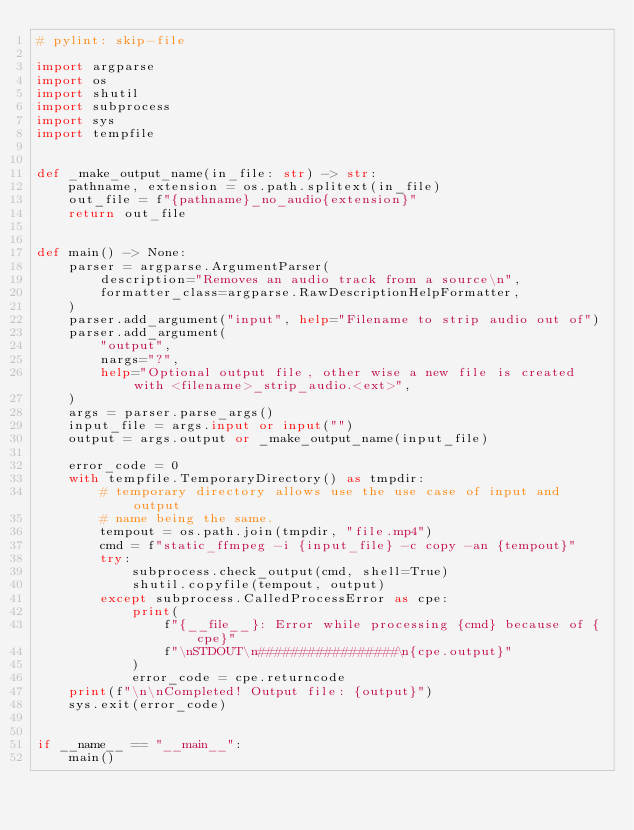<code> <loc_0><loc_0><loc_500><loc_500><_Python_># pylint: skip-file

import argparse
import os
import shutil
import subprocess
import sys
import tempfile


def _make_output_name(in_file: str) -> str:
    pathname, extension = os.path.splitext(in_file)
    out_file = f"{pathname}_no_audio{extension}"
    return out_file


def main() -> None:
    parser = argparse.ArgumentParser(
        description="Removes an audio track from a source\n",
        formatter_class=argparse.RawDescriptionHelpFormatter,
    )
    parser.add_argument("input", help="Filename to strip audio out of")
    parser.add_argument(
        "output",
        nargs="?",
        help="Optional output file, other wise a new file is created with <filename>_strip_audio.<ext>",
    )
    args = parser.parse_args()
    input_file = args.input or input("")
    output = args.output or _make_output_name(input_file)

    error_code = 0
    with tempfile.TemporaryDirectory() as tmpdir:
        # temporary directory allows use the use case of input and output
        # name being the same.
        tempout = os.path.join(tmpdir, "file.mp4")
        cmd = f"static_ffmpeg -i {input_file} -c copy -an {tempout}"
        try:
            subprocess.check_output(cmd, shell=True)
            shutil.copyfile(tempout, output)
        except subprocess.CalledProcessError as cpe:
            print(
                f"{__file__}: Error while processing {cmd} because of {cpe}"
                f"\nSTDOUT\n#################\n{cpe.output}"
            )
            error_code = cpe.returncode
    print(f"\n\nCompleted! Output file: {output}")
    sys.exit(error_code)


if __name__ == "__main__":
    main()
</code> 